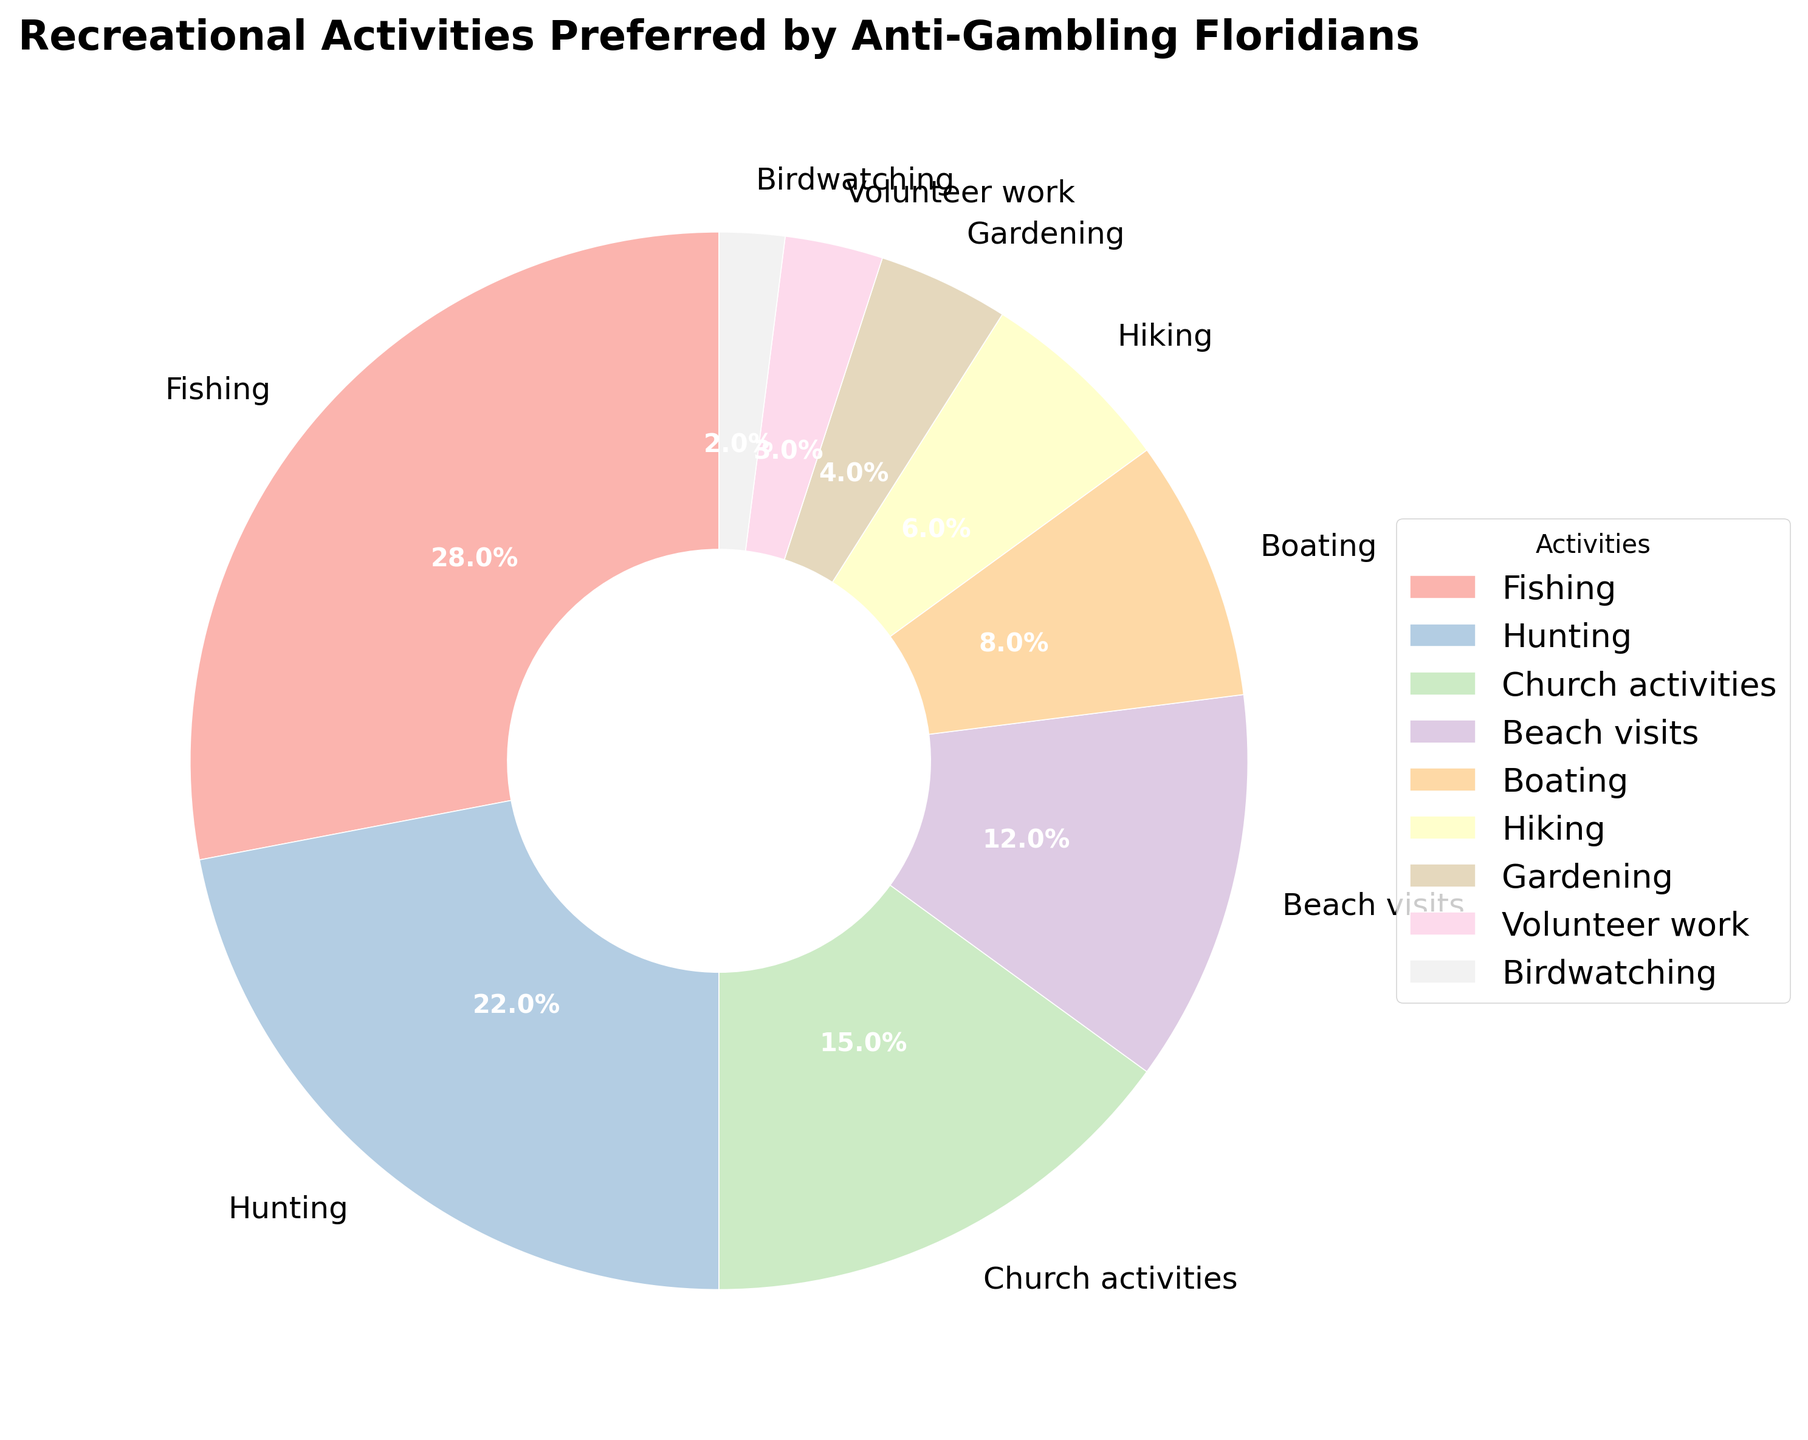Which activity occupies the largest portion of the pie chart? The activity that occupies the largest portion of the pie chart is the one with the highest percentage. According to the chart, Fishing accounts for 28% of recreational activities, which is the highest among all listed activities.
Answer: Fishing How much percentage do Fishing and Hunting combined account for? To find the combined percentage of Fishing and Hunting, sum their individual percentages. Fishing is 28% and Hunting is 22%. Therefore, the combined percentage is 28% + 22% = 50%.
Answer: 50% Which activity is represented by the smallest slice on the chart? The smallest slice on the chart corresponds to the activity with the lowest percentage. According to the chart, Birdwatching occupies 2%, which is the smallest portion.
Answer: Birdwatching How does the proportion of Church activities compare to the proportion of Beach visits? To compare Church activities to Beach visits, examine their percentages. Church activities account for 15%, while Beach visits account for 12%. Church activities are therefore 3% higher than Beach visits.
Answer: Church activities are 3% higher What is the average percentage of Boating, Hiking, and Gardening? To find the average percentage, sum the percentages of Boating, Hiking, and Gardening then divide by the count of activities. Boating is 8%, Hiking is 6%, and Gardening is 4%. Their total is 8% + 6% + 4% = 18%. The average is 18% / 3 = 6%.
Answer: 6% Which two activities together make up exactly 10% of the chart? From the chart, identify two activities whose percentages sum up to 10%. Only Volunteer work (3%) and Birdwatching (2%) sum to 5%, hence no pair sums directly to 10%.
Answer: No pair sums to 10% How much more popular is Fishing compared to Hiking? To determine how much more popular Fishing is compared to Hiking, subtract Hiking's percentage from Fishing's. Fishing is 28% and Hiking is 6%, so the difference is 28% - 6% = 22%.
Answer: 22% more popular Which activity makes up twice the percentage of Gardening? To find the activity that makes up twice the percentage of Gardening, multiply Gardening's percentage by 2. Gardening is 4%, so twice that is 4% * 2 = 8%. The activity with 8% is Boating.
Answer: Boating What's the total percentage for Fishing, Boating, and Hunting? To find the total percentage for Fishing, Boating, and Hunting, sum their individual percentages. Fishing is 28%, Boating is 8%, and Hunting is 22%. Therefore, the total is 28% + 8% + 22% = 58%.
Answer: 58% Which activity accounts for less than 5% of the recreational activities and what is its exact percentage? According to the chart, activities that account for less than 5% are Gardening, Volunteer work, and Birdwatching. Birdwatching is the one with the exact percentage of 2%.
Answer: Birdwatching with 2% 